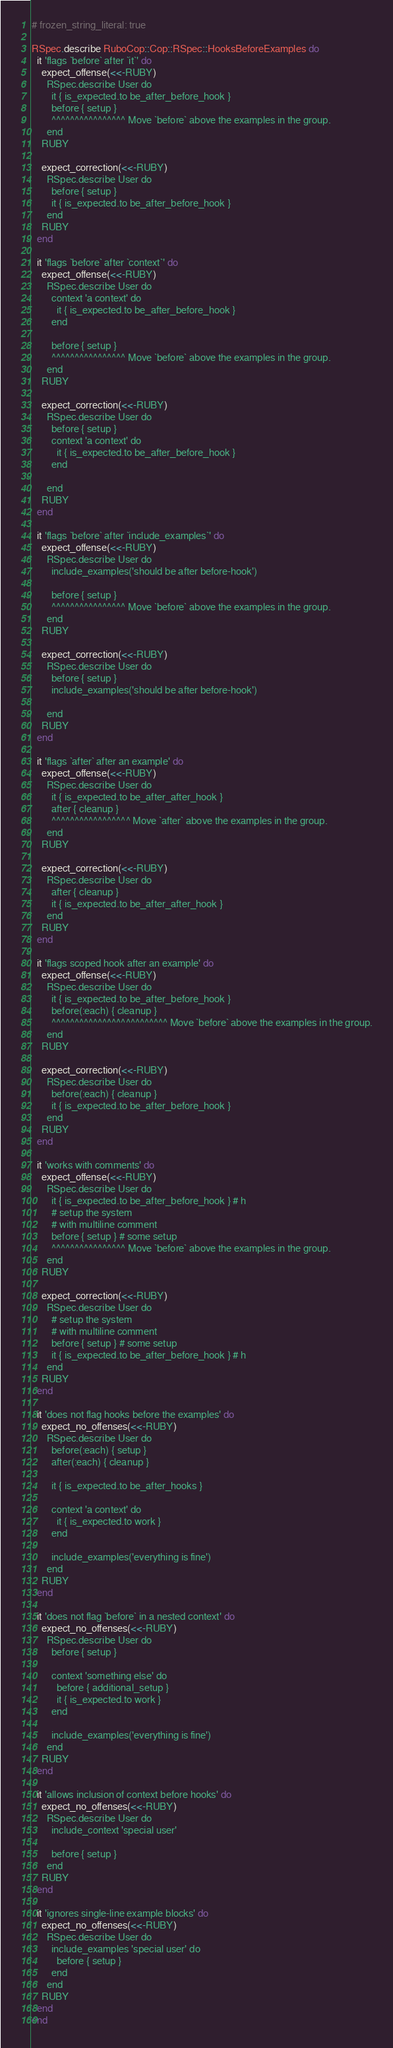<code> <loc_0><loc_0><loc_500><loc_500><_Ruby_># frozen_string_literal: true

RSpec.describe RuboCop::Cop::RSpec::HooksBeforeExamples do
  it 'flags `before` after `it`' do
    expect_offense(<<-RUBY)
      RSpec.describe User do
        it { is_expected.to be_after_before_hook }
        before { setup }
        ^^^^^^^^^^^^^^^^ Move `before` above the examples in the group.
      end
    RUBY

    expect_correction(<<-RUBY)
      RSpec.describe User do
        before { setup }
        it { is_expected.to be_after_before_hook }
      end
    RUBY
  end

  it 'flags `before` after `context`' do
    expect_offense(<<-RUBY)
      RSpec.describe User do
        context 'a context' do
          it { is_expected.to be_after_before_hook }
        end

        before { setup }
        ^^^^^^^^^^^^^^^^ Move `before` above the examples in the group.
      end
    RUBY

    expect_correction(<<-RUBY)
      RSpec.describe User do
        before { setup }
        context 'a context' do
          it { is_expected.to be_after_before_hook }
        end

      end
    RUBY
  end

  it 'flags `before` after `include_examples`' do
    expect_offense(<<-RUBY)
      RSpec.describe User do
        include_examples('should be after before-hook')

        before { setup }
        ^^^^^^^^^^^^^^^^ Move `before` above the examples in the group.
      end
    RUBY

    expect_correction(<<-RUBY)
      RSpec.describe User do
        before { setup }
        include_examples('should be after before-hook')

      end
    RUBY
  end

  it 'flags `after` after an example' do
    expect_offense(<<-RUBY)
      RSpec.describe User do
        it { is_expected.to be_after_after_hook }
        after { cleanup }
        ^^^^^^^^^^^^^^^^^ Move `after` above the examples in the group.
      end
    RUBY

    expect_correction(<<-RUBY)
      RSpec.describe User do
        after { cleanup }
        it { is_expected.to be_after_after_hook }
      end
    RUBY
  end

  it 'flags scoped hook after an example' do
    expect_offense(<<-RUBY)
      RSpec.describe User do
        it { is_expected.to be_after_before_hook }
        before(:each) { cleanup }
        ^^^^^^^^^^^^^^^^^^^^^^^^^ Move `before` above the examples in the group.
      end
    RUBY

    expect_correction(<<-RUBY)
      RSpec.describe User do
        before(:each) { cleanup }
        it { is_expected.to be_after_before_hook }
      end
    RUBY
  end

  it 'works with comments' do
    expect_offense(<<-RUBY)
      RSpec.describe User do
        it { is_expected.to be_after_before_hook } # h
        # setup the system
        # with multiline comment
        before { setup } # some setup
        ^^^^^^^^^^^^^^^^ Move `before` above the examples in the group.
      end
    RUBY

    expect_correction(<<-RUBY)
      RSpec.describe User do
        # setup the system
        # with multiline comment
        before { setup } # some setup
        it { is_expected.to be_after_before_hook } # h
      end
    RUBY
  end

  it 'does not flag hooks before the examples' do
    expect_no_offenses(<<-RUBY)
      RSpec.describe User do
        before(:each) { setup }
        after(:each) { cleanup }

        it { is_expected.to be_after_hooks }

        context 'a context' do
          it { is_expected.to work }
        end

        include_examples('everything is fine')
      end
    RUBY
  end

  it 'does not flag `before` in a nested context' do
    expect_no_offenses(<<-RUBY)
      RSpec.describe User do
        before { setup }

        context 'something else' do
          before { additional_setup }
          it { is_expected.to work }
        end

        include_examples('everything is fine')
      end
    RUBY
  end

  it 'allows inclusion of context before hooks' do
    expect_no_offenses(<<-RUBY)
      RSpec.describe User do
        include_context 'special user'

        before { setup }
      end
    RUBY
  end

  it 'ignores single-line example blocks' do
    expect_no_offenses(<<-RUBY)
      RSpec.describe User do
        include_examples 'special user' do
          before { setup }
        end
      end
    RUBY
  end
end
</code> 